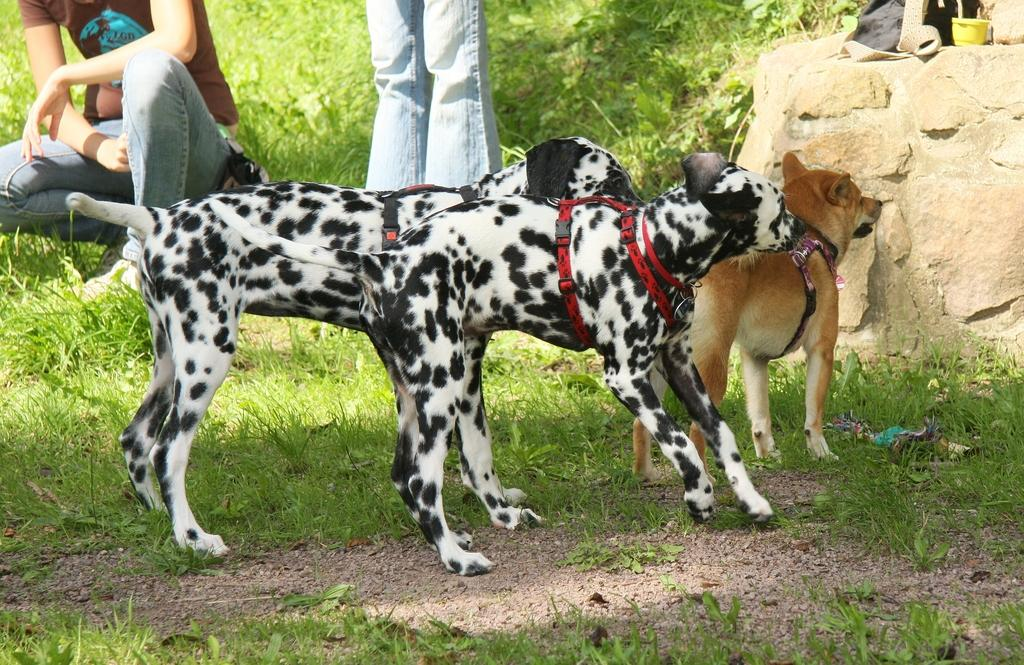How many dogs are in the image? There are three dogs in the image, two black and white dogs and one brown dog. What is the surface the dogs are standing on? The dogs are standing on a grassy surface. Can you describe the background of the image? In the background of the image, there are two persons and a rock with a bag on it. What month is it in the image? The month cannot be determined from the image, as there is no information about the time of year. 